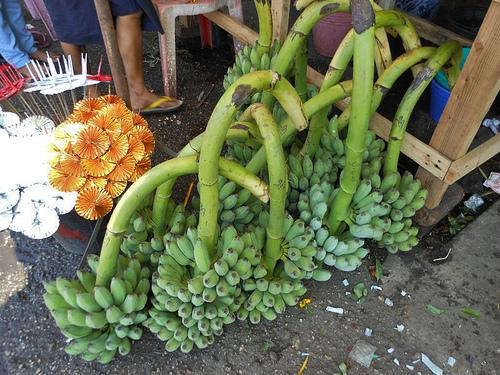Question: what are the green things?
Choices:
A. Peas.
B. Leaves.
C. Okra.
D. Bananas.
Answer with the letter. Answer: D Question: what color is the flip flop?
Choices:
A. Teal.
B. Purple.
C. Yellow.
D. Neon.
Answer with the letter. Answer: C Question: how many legs can you see?
Choices:
A. 12.
B. 13.
C. 5.
D. 4.
Answer with the letter. Answer: D Question: where are the people standing?
Choices:
A. On a platform.
B. Under a tent.
C. At the bar.
D. Behind the bananas.
Answer with the letter. Answer: D 